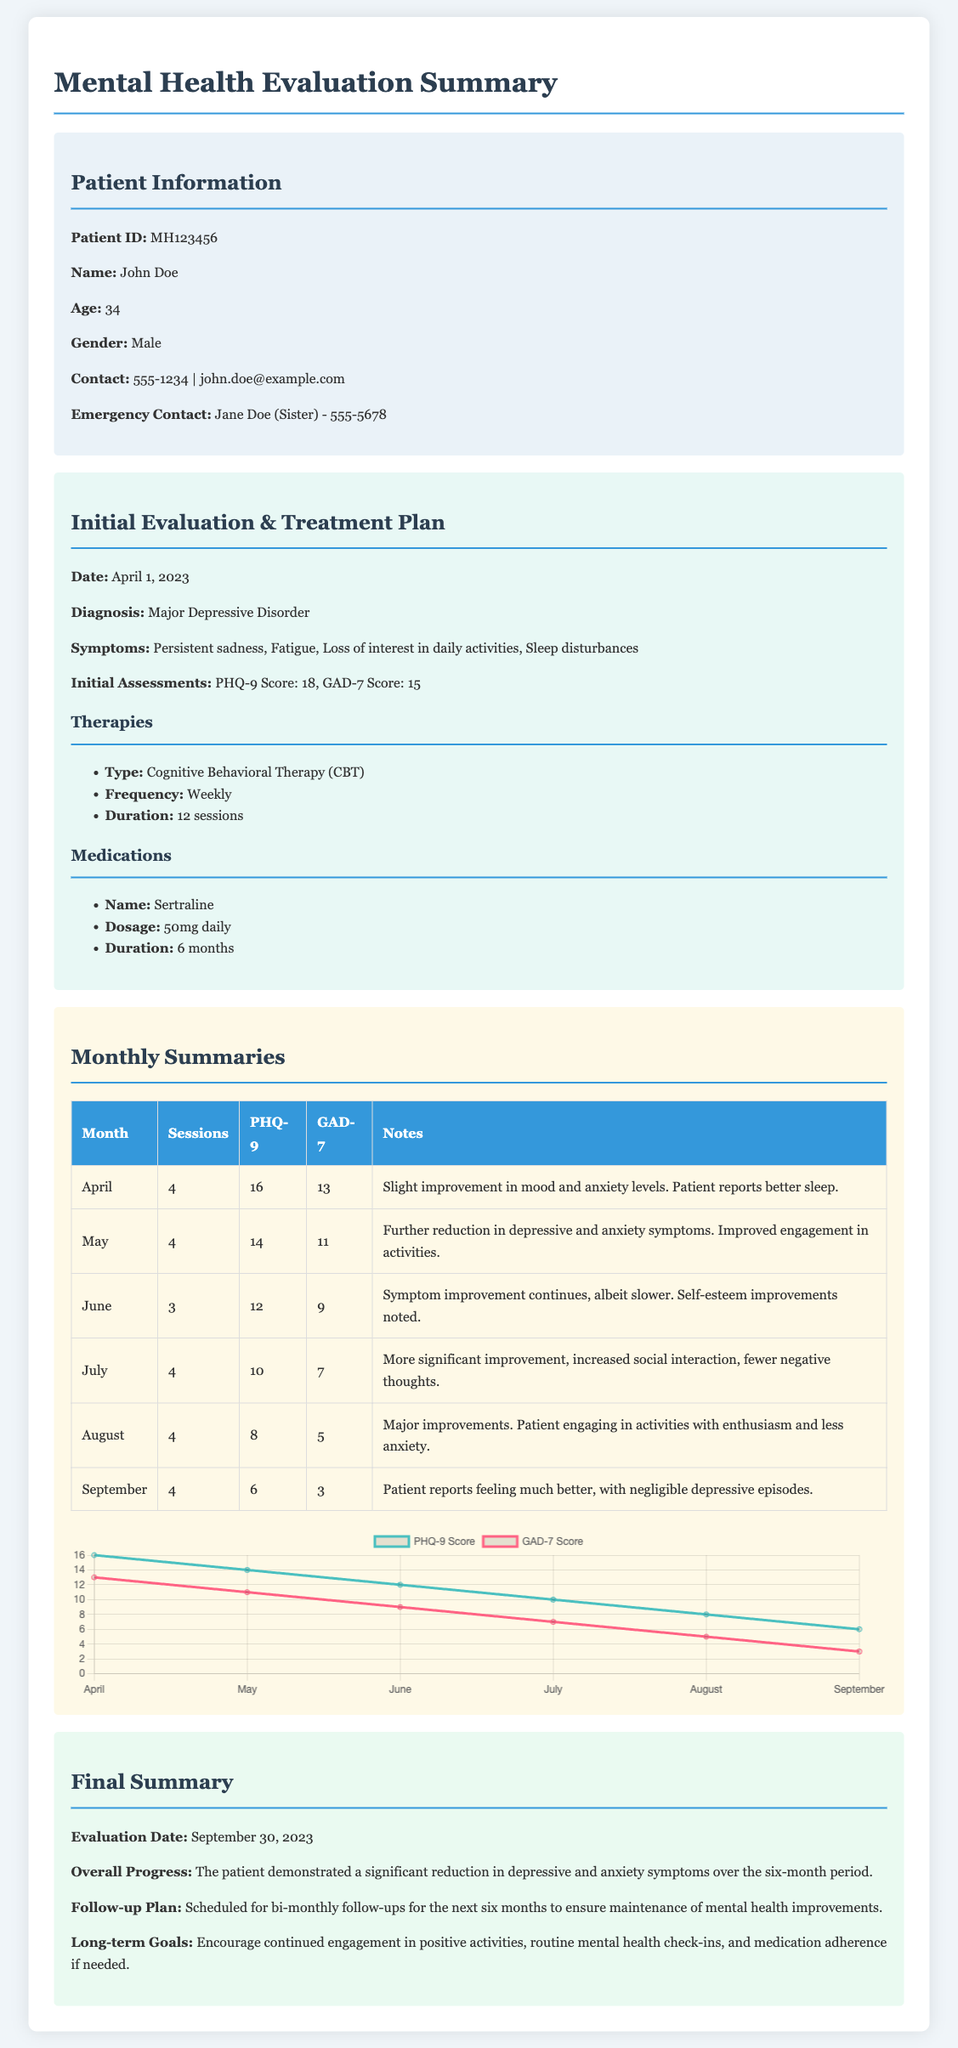What is the patient's name? The patient's name is clearly stated in the patient information section of the document.
Answer: John Doe What is the diagnosis? The diagnosis is mentioned in the treatment plan section of the document.
Answer: Major Depressive Disorder How many sessions were conducted in July? The number of sessions is listed in the monthly summaries, specifically for July.
Answer: 4 What was the PHQ-9 score in April? The PHQ-9 score for April is noted in the monthly summaries table.
Answer: 16 What medication was prescribed? The prescribed medication is detailed in the treatment plan section.
Answer: Sertraline What is the follow-up plan? The follow-up plan is outlined in the final summary of the document.
Answer: Bi-monthly follow-ups What was the GAD-7 score in September? The GAD-7 score for September is presented in the monthly summaries table.
Answer: 3 How many months did the therapy sessions span? The duration of therapy sessions can be inferred from the dates and evaluations mentioned throughout the document.
Answer: 6 months What is a long-term goal mentioned in the summary? The long-term goals are explicitly listed in the final summary section of the document.
Answer: Continued engagement in positive activities 